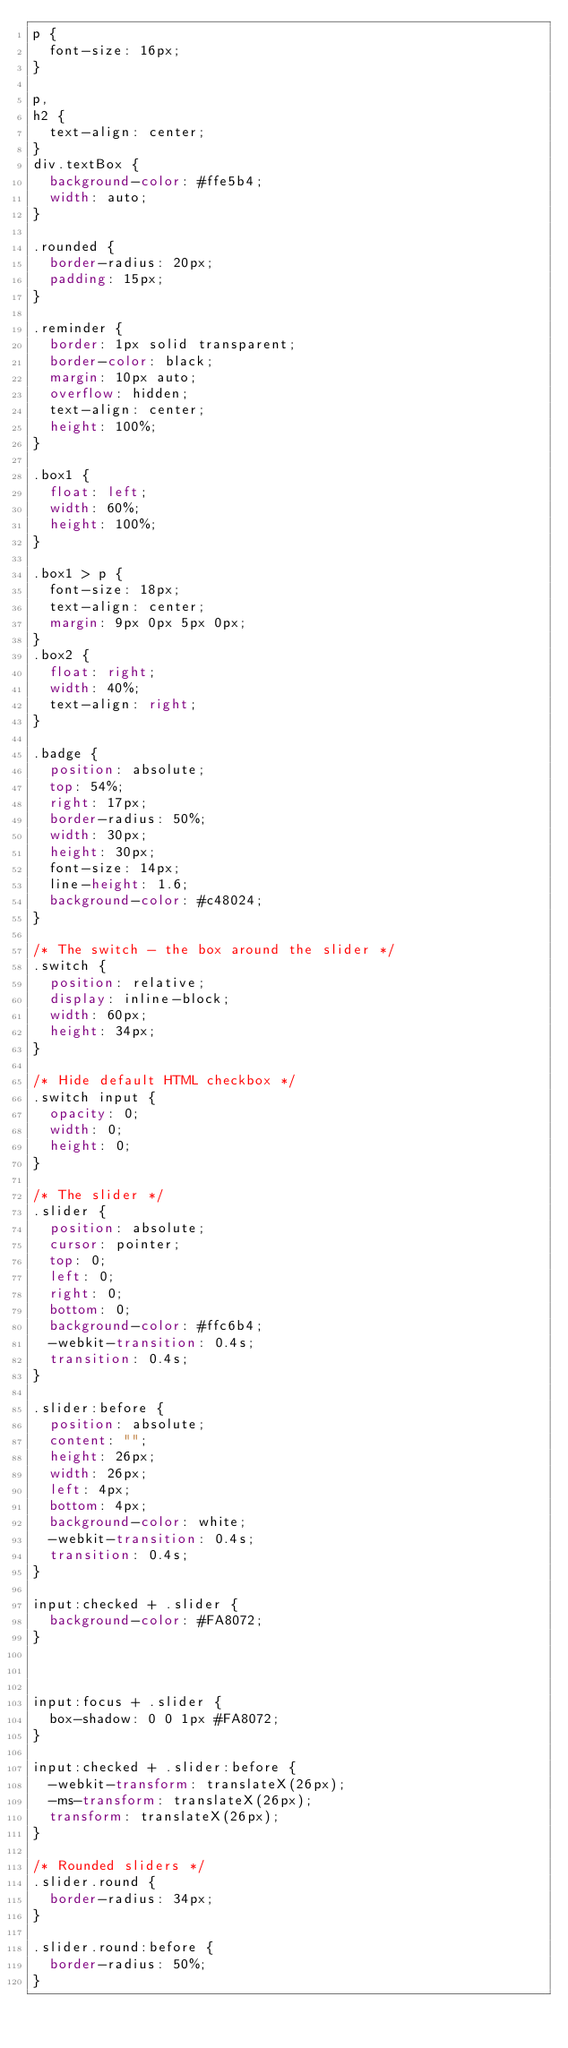<code> <loc_0><loc_0><loc_500><loc_500><_CSS_>p {
  font-size: 16px;
}

p,
h2 {
  text-align: center;
}
div.textBox {
  background-color: #ffe5b4;
  width: auto;
}

.rounded {
  border-radius: 20px;
  padding: 15px;
}

.reminder {
  border: 1px solid transparent;
  border-color: black;
  margin: 10px auto;
  overflow: hidden;
  text-align: center;
  height: 100%;
}

.box1 {
  float: left;
  width: 60%;
  height: 100%;
}

.box1 > p {
  font-size: 18px;
  text-align: center;
  margin: 9px 0px 5px 0px;
}
.box2 {
  float: right;
  width: 40%;
  text-align: right;
}

.badge {
  position: absolute;
  top: 54%;
  right: 17px;
  border-radius: 50%;
  width: 30px;
  height: 30px;
  font-size: 14px;
  line-height: 1.6;
  background-color: #c48024;
}

/* The switch - the box around the slider */
.switch {
  position: relative;
  display: inline-block;
  width: 60px;
  height: 34px;
}

/* Hide default HTML checkbox */
.switch input {
  opacity: 0;
  width: 0;
  height: 0;
}

/* The slider */
.slider {
  position: absolute;
  cursor: pointer;
  top: 0;
  left: 0;
  right: 0;
  bottom: 0;
  background-color: #ffc6b4;
  -webkit-transition: 0.4s;
  transition: 0.4s;
}

.slider:before {
  position: absolute;
  content: "";
  height: 26px;
  width: 26px;
  left: 4px;
  bottom: 4px;
  background-color: white;
  -webkit-transition: 0.4s;
  transition: 0.4s;
}

input:checked + .slider {
  background-color: #FA8072;
}



input:focus + .slider {
  box-shadow: 0 0 1px #FA8072;
}

input:checked + .slider:before {
  -webkit-transform: translateX(26px);
  -ms-transform: translateX(26px);
  transform: translateX(26px);
}

/* Rounded sliders */
.slider.round {
  border-radius: 34px;
}

.slider.round:before {
  border-radius: 50%;
}

</code> 